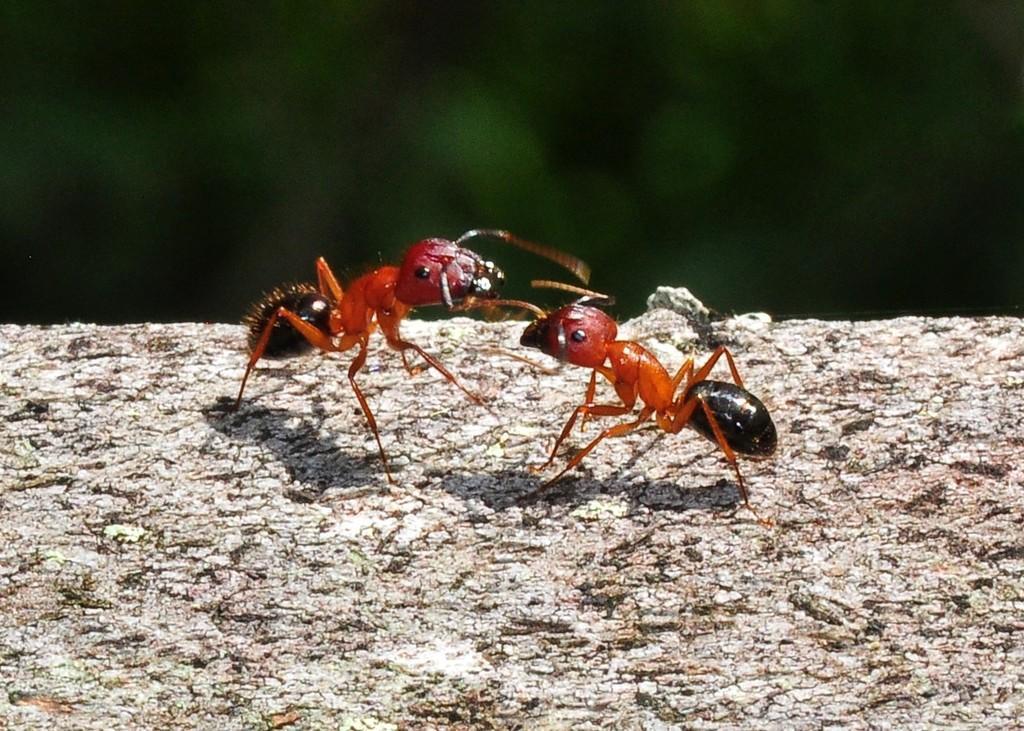Please provide a concise description of this image. In this image there are two ants on a wooden log. 